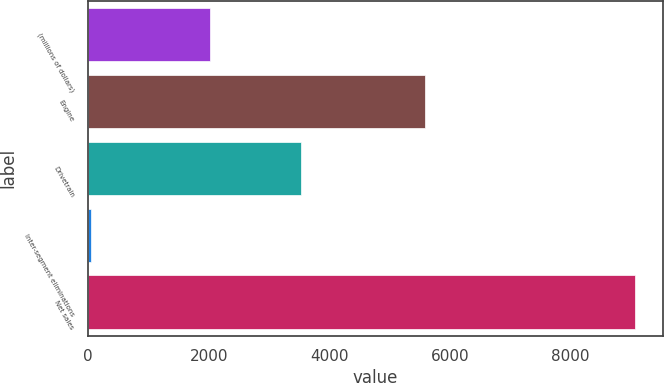Convert chart to OTSL. <chart><loc_0><loc_0><loc_500><loc_500><bar_chart><fcel>(millions of dollars)<fcel>Engine<fcel>Drivetrain<fcel>Inter-segment eliminations<fcel>Net sales<nl><fcel>2016<fcel>5590.1<fcel>3523.7<fcel>42.8<fcel>9071<nl></chart> 